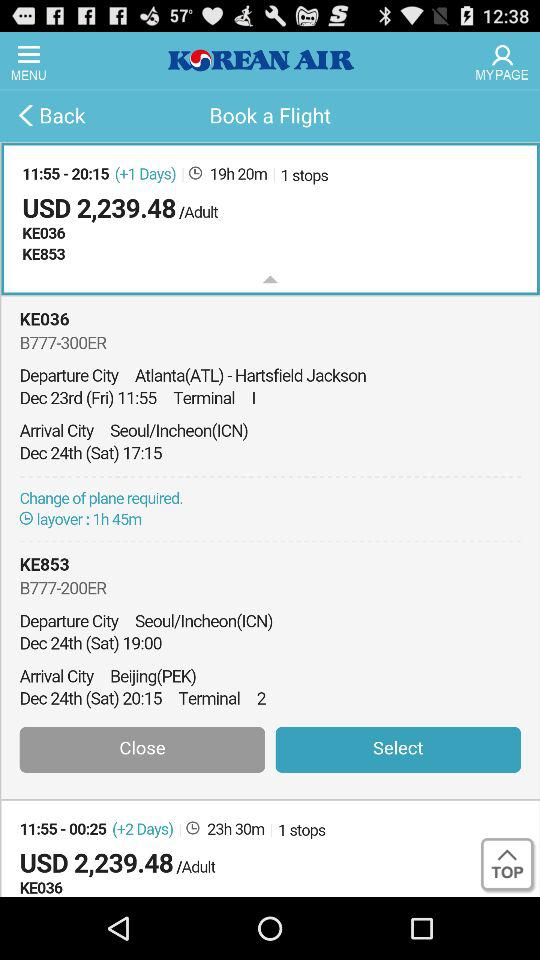What is the name of the application? The name of the application is "KOREAN AIR". 